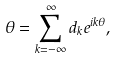Convert formula to latex. <formula><loc_0><loc_0><loc_500><loc_500>\theta = \sum _ { k = - \infty } ^ { \infty } d _ { k } e ^ { i k \theta } ,</formula> 